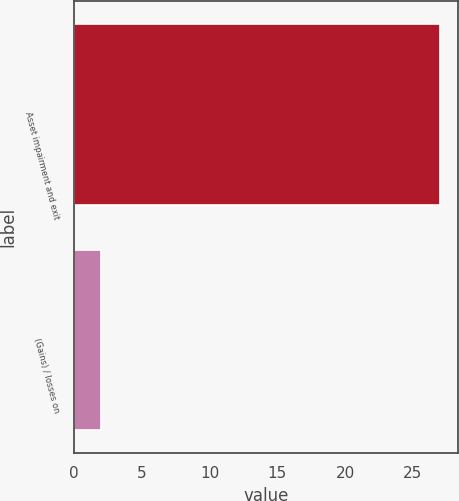<chart> <loc_0><loc_0><loc_500><loc_500><bar_chart><fcel>Asset impairment and exit<fcel>(Gains) / losses on<nl><fcel>27<fcel>2<nl></chart> 